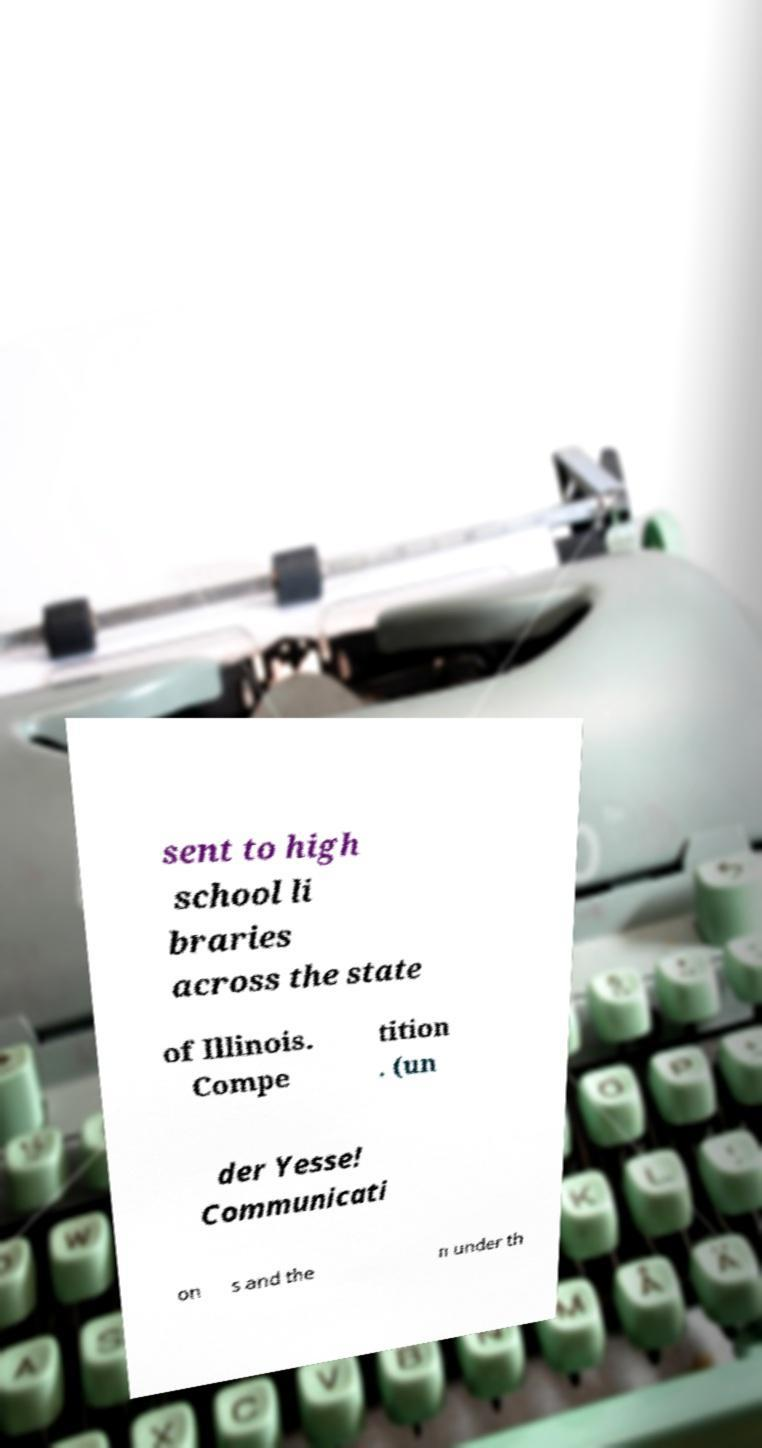There's text embedded in this image that I need extracted. Can you transcribe it verbatim? sent to high school li braries across the state of Illinois. Compe tition . (un der Yesse! Communicati on s and the n under th 